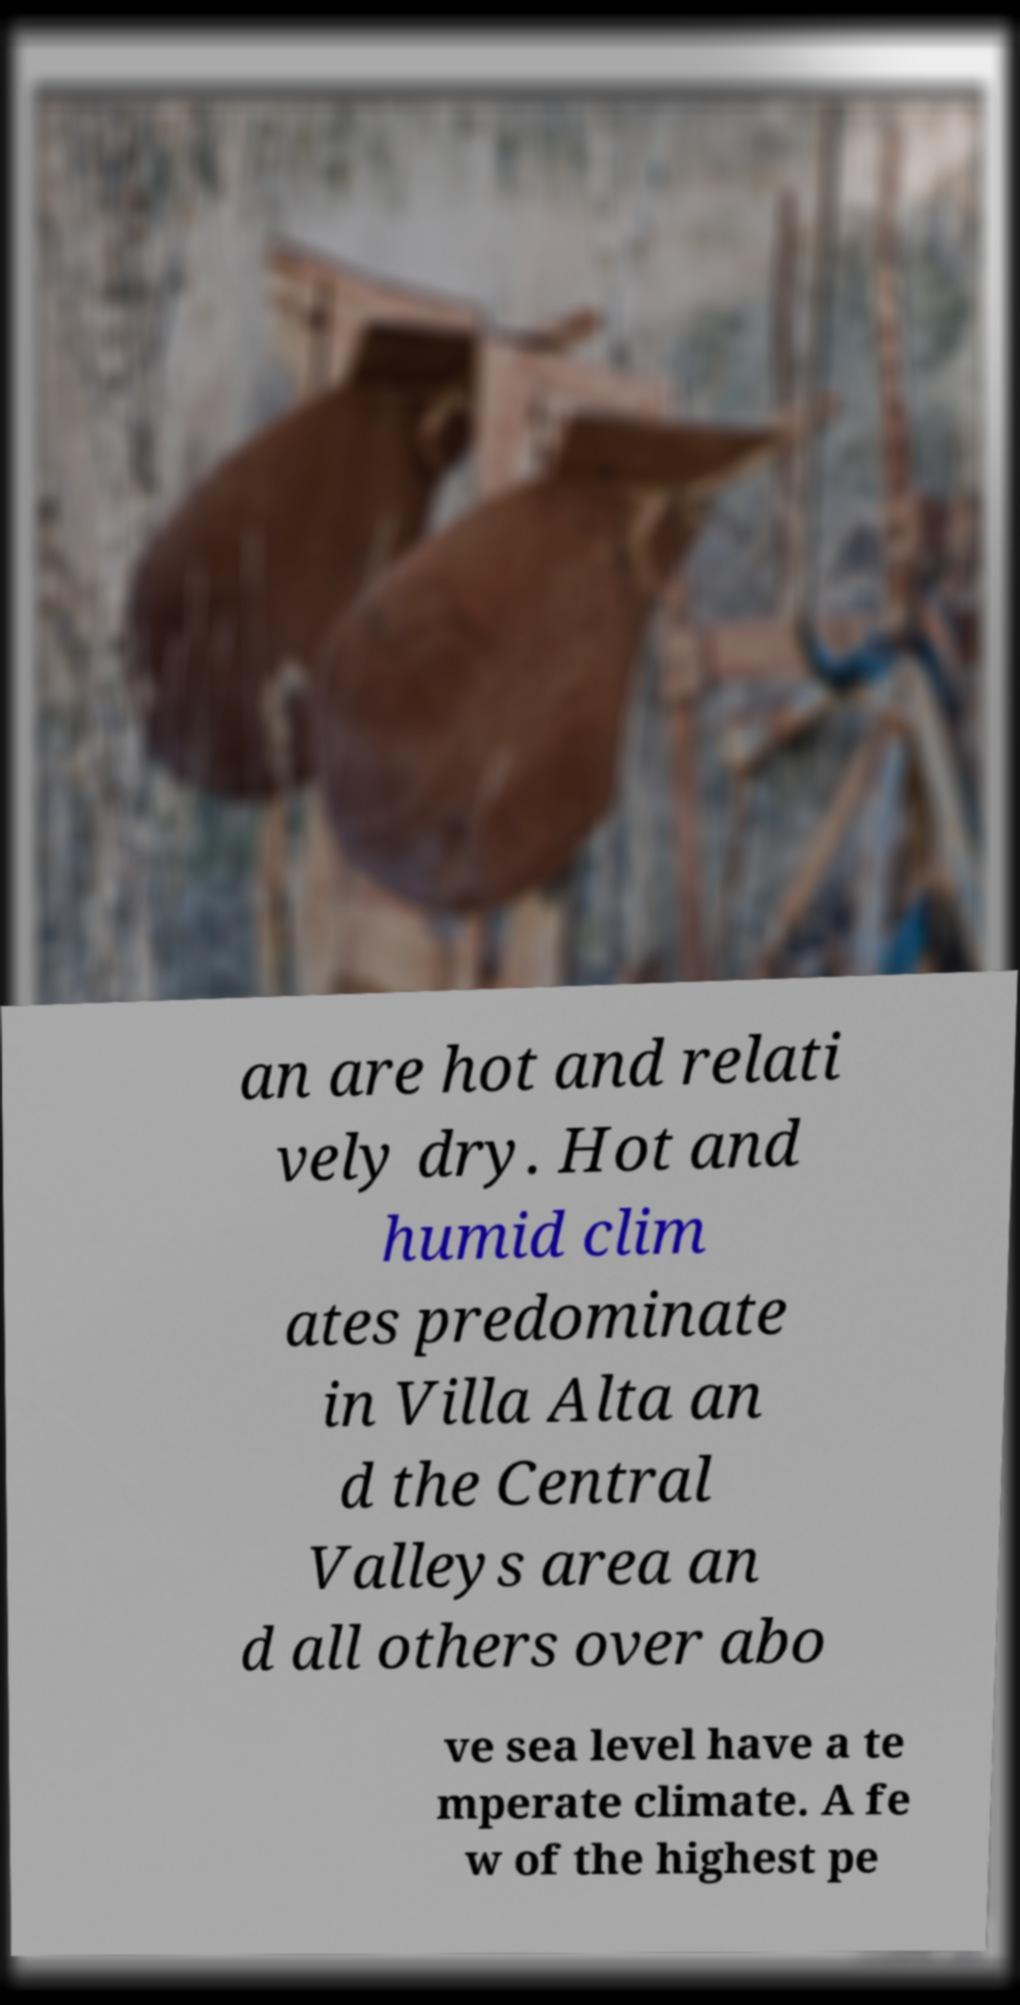What messages or text are displayed in this image? I need them in a readable, typed format. an are hot and relati vely dry. Hot and humid clim ates predominate in Villa Alta an d the Central Valleys area an d all others over abo ve sea level have a te mperate climate. A fe w of the highest pe 